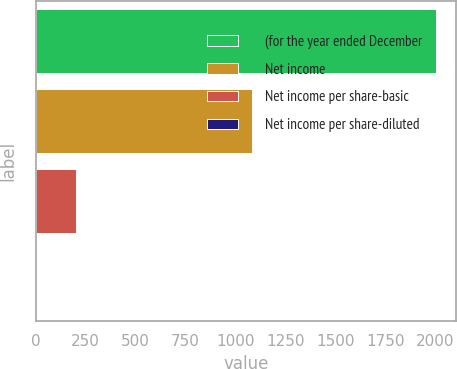<chart> <loc_0><loc_0><loc_500><loc_500><bar_chart><fcel>(for the year ended December<fcel>Net income<fcel>Net income per share-basic<fcel>Net income per share-diluted<nl><fcel>2004<fcel>1080<fcel>201.82<fcel>1.58<nl></chart> 